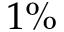Convert formula to latex. <formula><loc_0><loc_0><loc_500><loc_500>1 \%</formula> 